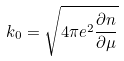Convert formula to latex. <formula><loc_0><loc_0><loc_500><loc_500>k _ { 0 } = \sqrt { 4 \pi e ^ { 2 } \frac { \partial n } { \partial \mu } }</formula> 